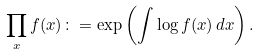Convert formula to latex. <formula><loc_0><loc_0><loc_500><loc_500>\prod _ { x } f ( x ) \colon = \exp \left ( \int \log f ( x ) \, d x \right ) .</formula> 